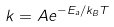Convert formula to latex. <formula><loc_0><loc_0><loc_500><loc_500>k = A e ^ { - E _ { a } / k _ { B } T }</formula> 